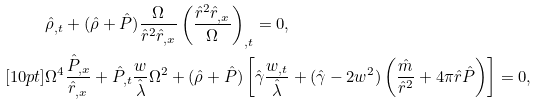Convert formula to latex. <formula><loc_0><loc_0><loc_500><loc_500>& \hat { \rho } _ { , t } + ( \hat { \rho } + \hat { P } ) \frac { \Omega } { \hat { r } ^ { 2 } \hat { r } _ { , x } } \left ( \frac { \hat { r } ^ { 2 } \hat { r } _ { , x } } { \Omega } \right ) _ { , t } = 0 , \\ [ 1 0 p t ] & \Omega ^ { 4 } \frac { \hat { P } _ { , x } } { \hat { r } _ { , x } } + \hat { P } _ { , t } \frac { w } { \hat { \lambda } } \Omega ^ { 2 } + ( \hat { \rho } + \hat { P } ) \left [ \hat { \gamma } \frac { w _ { , t } } { \hat { \lambda } } + ( \hat { \gamma } - 2 w ^ { 2 } ) \left ( \frac { \hat { m } } { \hat { r } ^ { 2 } } + 4 \pi \hat { r } \hat { P } \right ) \right ] = 0 ,</formula> 